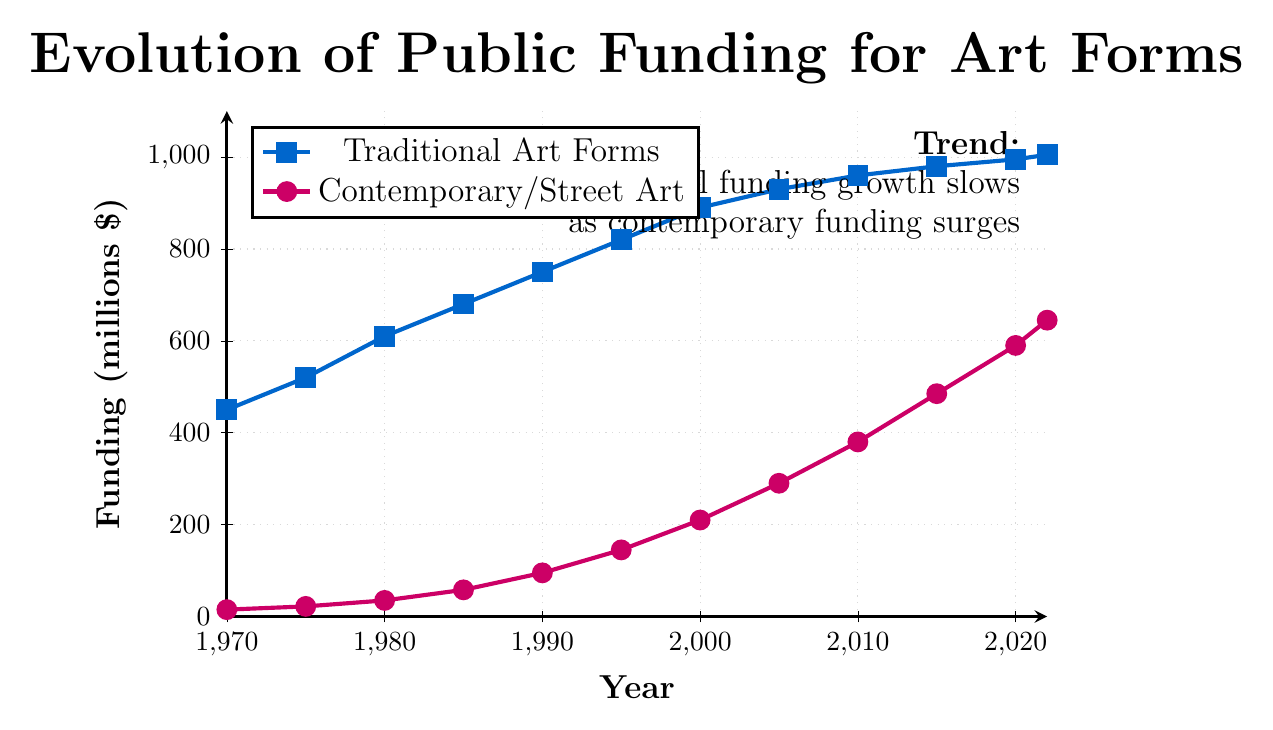What was the total public funding for both Traditional and Contemporary/Street Art in 1990? To find the total funding in 1990, we add the funding for Traditional Art Forms and Contemporary/Street Art. For Traditional Art Forms, it is $750 million, and for Contemporary/Street Art, it is $95 million. Thus, $750 + $95 = $845 million.
Answer: $845 million How much more funding did Traditional Art Forms receive than Contemporary/Street Art in 2022? In 2022, Traditional Art Forms received $1005 million, and Contemporary/Street Art received $645 million. To find the difference, subtract $645 from $1005. Thus, $1005 - $645 = $360 million.
Answer: $360 million Which art form showed a greater growth rate from 2000 to 2022? To determine the growth rate, we calculate the differences in funding for each art form between 2000 and 2022. For Traditional Art Forms, it grew from $890 million to $1005 million, an increase of $115 million. For Contemporary/Street Art, it grew from $210 million to $645 million, an increase of $435 million. Since $435 million is greater than $115 million, Contemporary/Street Art showed a greater growth rate.
Answer: Contemporary/Street Art In what year did public funding for Contemporary/Street Art first exceed $100 million? By examining the trend line for Contemporary/Street Art, we can see that funding reached and exceeded $100 million between 1990 and 1995. Specifically, it was $145 million in 1995. Therefore, the first year it exceeded $100 million was 1995.
Answer: 1995 Compare the funding levels for both art forms in 2005. Which art form had higher funding, and by how much? In 2005, the funding for Traditional Art Forms was $930 million, and for Contemporary/Street Art, it was $290 million. Traditional Art Forms had higher funding. To find the difference, subtract $290 from $930. Thus, $930 - $290 = $640 million.
Answer: Traditional Art Forms by $640 million What is the average funding for Traditional Art Forms over the entire period? Sum the funding values for Traditional Art Forms from 1970 ($450 million) to 2022 ($1005 million) and divide by the number of data points (12 years). Sum = $450 + $520 + $610 + $680 + $750 + $820 + $890 + $930 + $960 + $980 + $995 + $1005 = $9590 million. Average = $9590 / 12 = $799.17 million.
Answer: $799.17 million What is the ratio of funding for Traditional Art Forms to Contemporary/Street Art in 2010? In 2010, funding for Traditional Art Forms was $960 million, and for Contemporary/Street Art, it was $380 million. The ratio is calculated by dividing the funding for Traditional Art Forms by the funding for Contemporary/Street Art. Thus, $960 / $380 = 2.53.
Answer: 2.53 